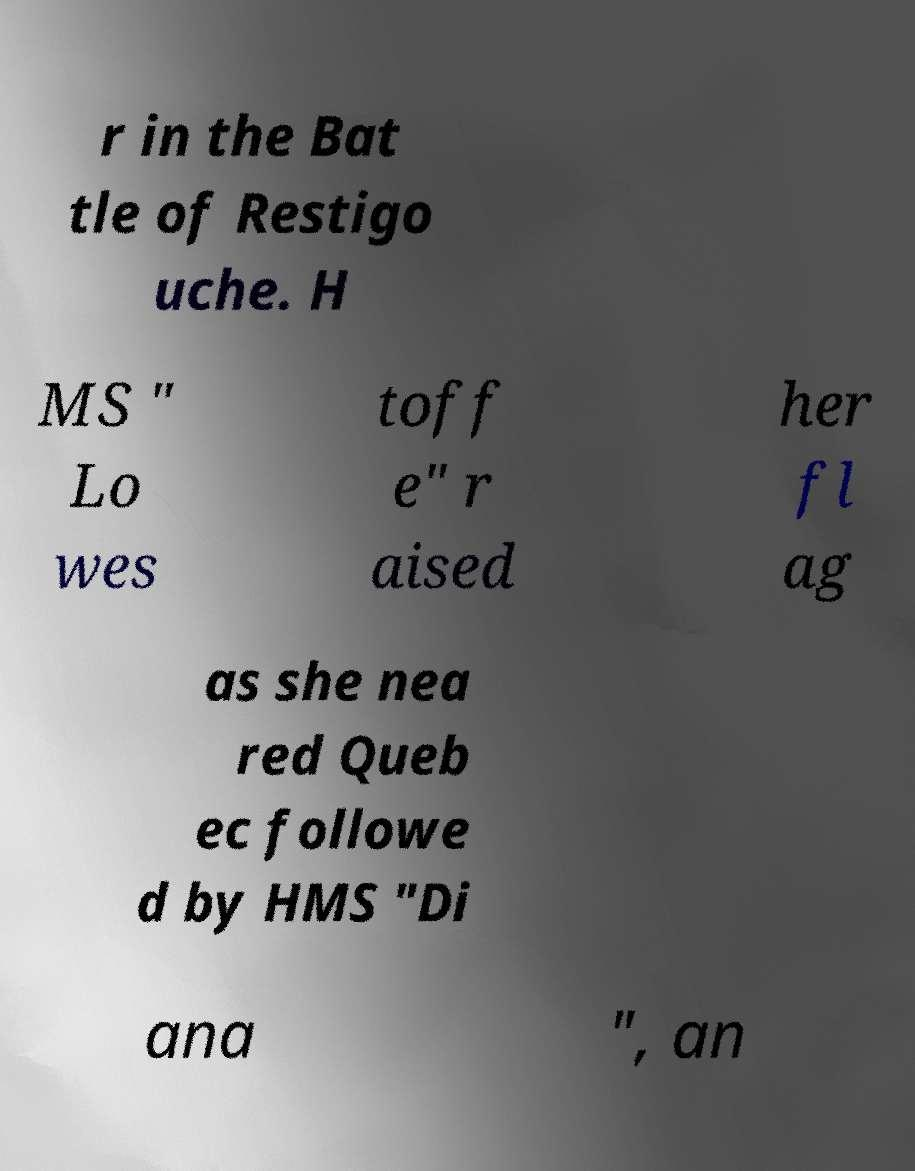Can you accurately transcribe the text from the provided image for me? r in the Bat tle of Restigo uche. H MS " Lo wes toff e" r aised her fl ag as she nea red Queb ec followe d by HMS "Di ana ", an 